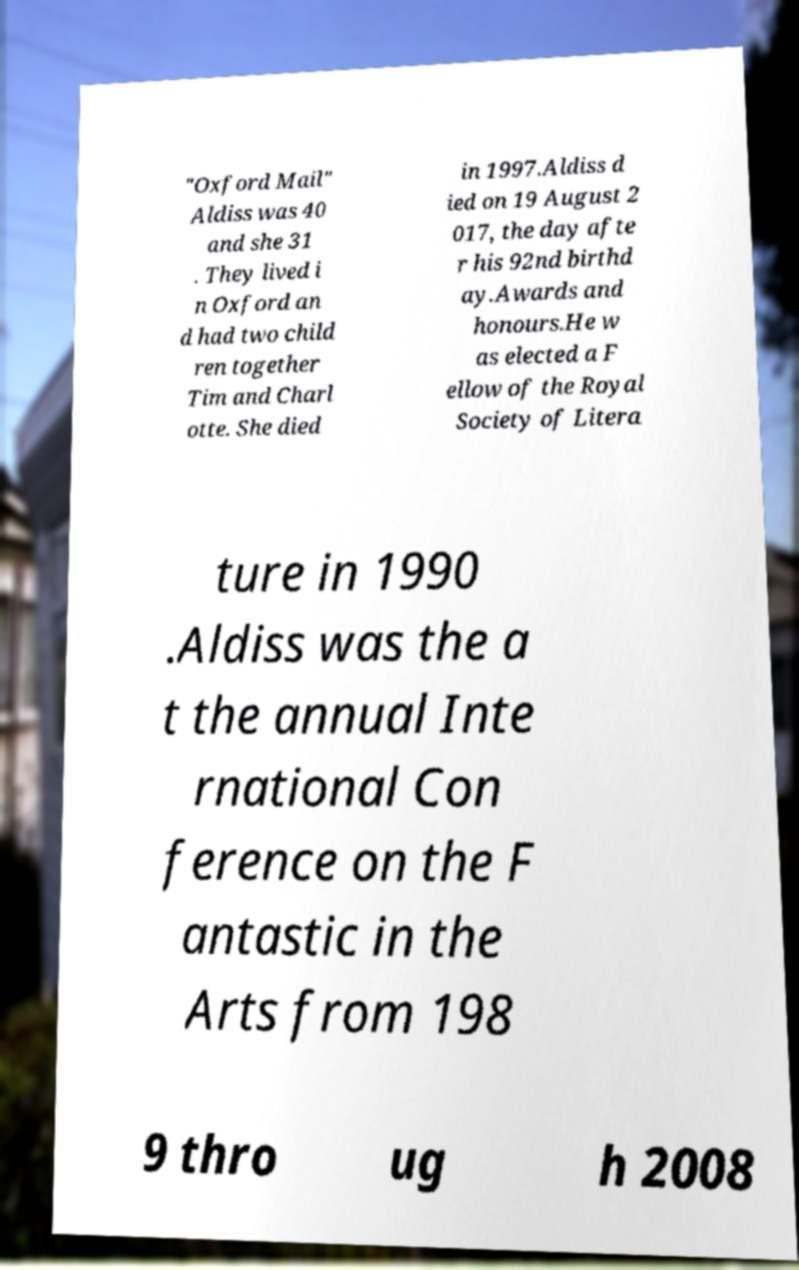There's text embedded in this image that I need extracted. Can you transcribe it verbatim? "Oxford Mail" Aldiss was 40 and she 31 . They lived i n Oxford an d had two child ren together Tim and Charl otte. She died in 1997.Aldiss d ied on 19 August 2 017, the day afte r his 92nd birthd ay.Awards and honours.He w as elected a F ellow of the Royal Society of Litera ture in 1990 .Aldiss was the a t the annual Inte rnational Con ference on the F antastic in the Arts from 198 9 thro ug h 2008 